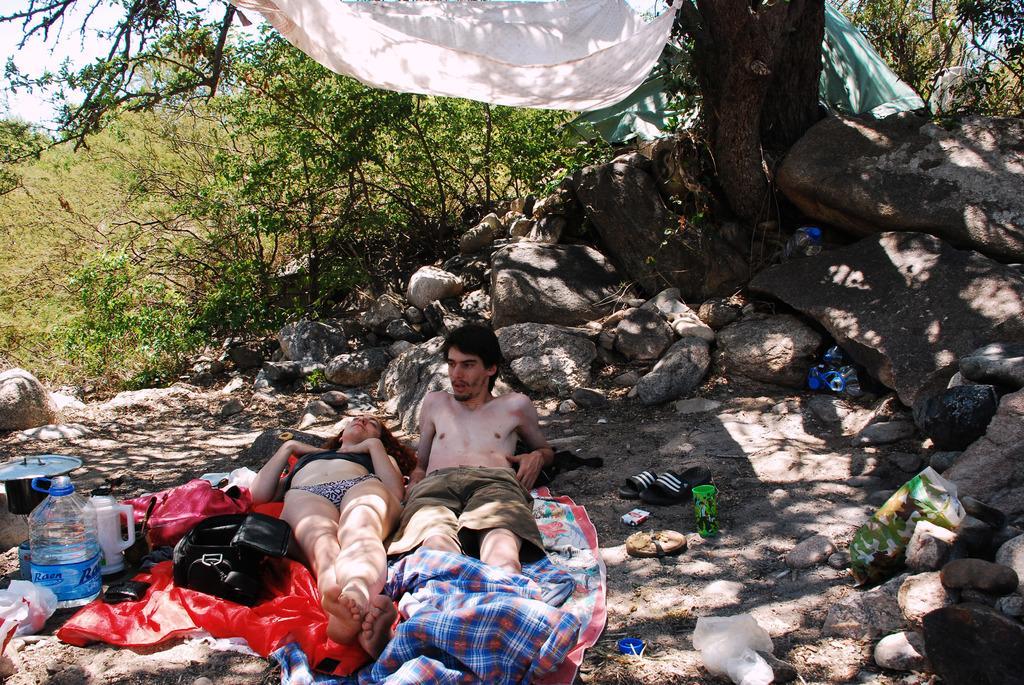Could you give a brief overview of what you see in this image? There are two people and she is laying on a cloth. We can see clothes,water bottle,jug,footwear,covers and objects. In the background we can see trees,clothes,stones and sky. 